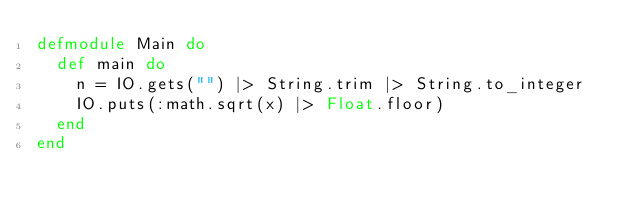Convert code to text. <code><loc_0><loc_0><loc_500><loc_500><_Elixir_>defmodule Main do
  def main do
    n = IO.gets("") |> String.trim |> String.to_integer
    IO.puts(:math.sqrt(x) |> Float.floor)
  end
end</code> 